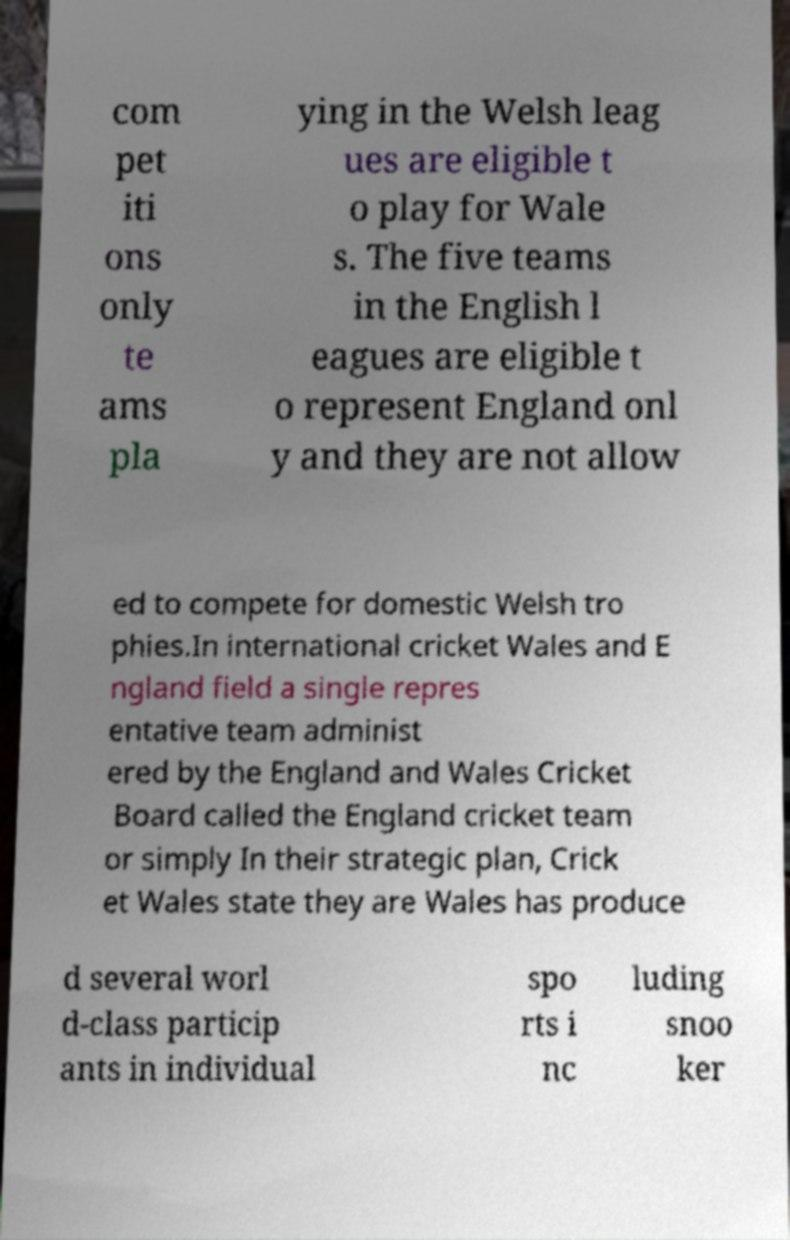Can you read and provide the text displayed in the image?This photo seems to have some interesting text. Can you extract and type it out for me? com pet iti ons only te ams pla ying in the Welsh leag ues are eligible t o play for Wale s. The five teams in the English l eagues are eligible t o represent England onl y and they are not allow ed to compete for domestic Welsh tro phies.In international cricket Wales and E ngland field a single repres entative team administ ered by the England and Wales Cricket Board called the England cricket team or simply In their strategic plan, Crick et Wales state they are Wales has produce d several worl d-class particip ants in individual spo rts i nc luding snoo ker 